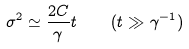Convert formula to latex. <formula><loc_0><loc_0><loc_500><loc_500>\sigma ^ { 2 } \simeq \frac { 2 C } { \gamma } t \quad ( t \gg \gamma ^ { - 1 } )</formula> 